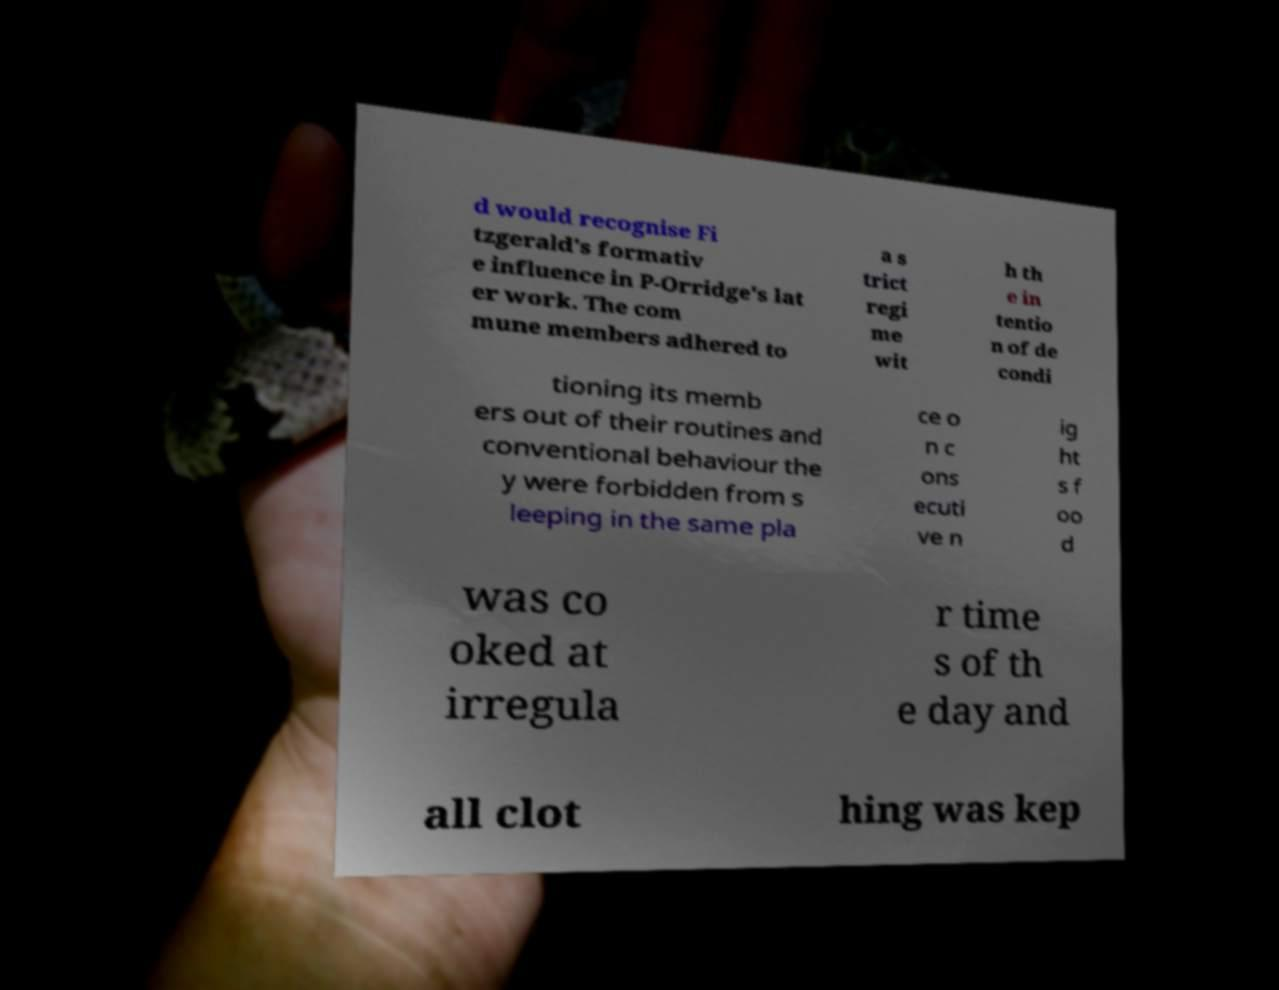Please read and relay the text visible in this image. What does it say? d would recognise Fi tzgerald's formativ e influence in P-Orridge's lat er work. The com mune members adhered to a s trict regi me wit h th e in tentio n of de condi tioning its memb ers out of their routines and conventional behaviour the y were forbidden from s leeping in the same pla ce o n c ons ecuti ve n ig ht s f oo d was co oked at irregula r time s of th e day and all clot hing was kep 